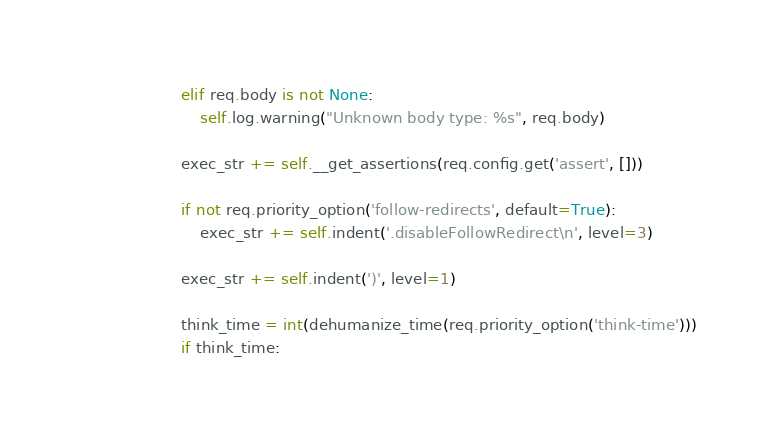Convert code to text. <code><loc_0><loc_0><loc_500><loc_500><_Python_>            elif req.body is not None:
                self.log.warning("Unknown body type: %s", req.body)

            exec_str += self.__get_assertions(req.config.get('assert', []))

            if not req.priority_option('follow-redirects', default=True):
                exec_str += self.indent('.disableFollowRedirect\n', level=3)

            exec_str += self.indent(')', level=1)

            think_time = int(dehumanize_time(req.priority_option('think-time')))
            if think_time:</code> 